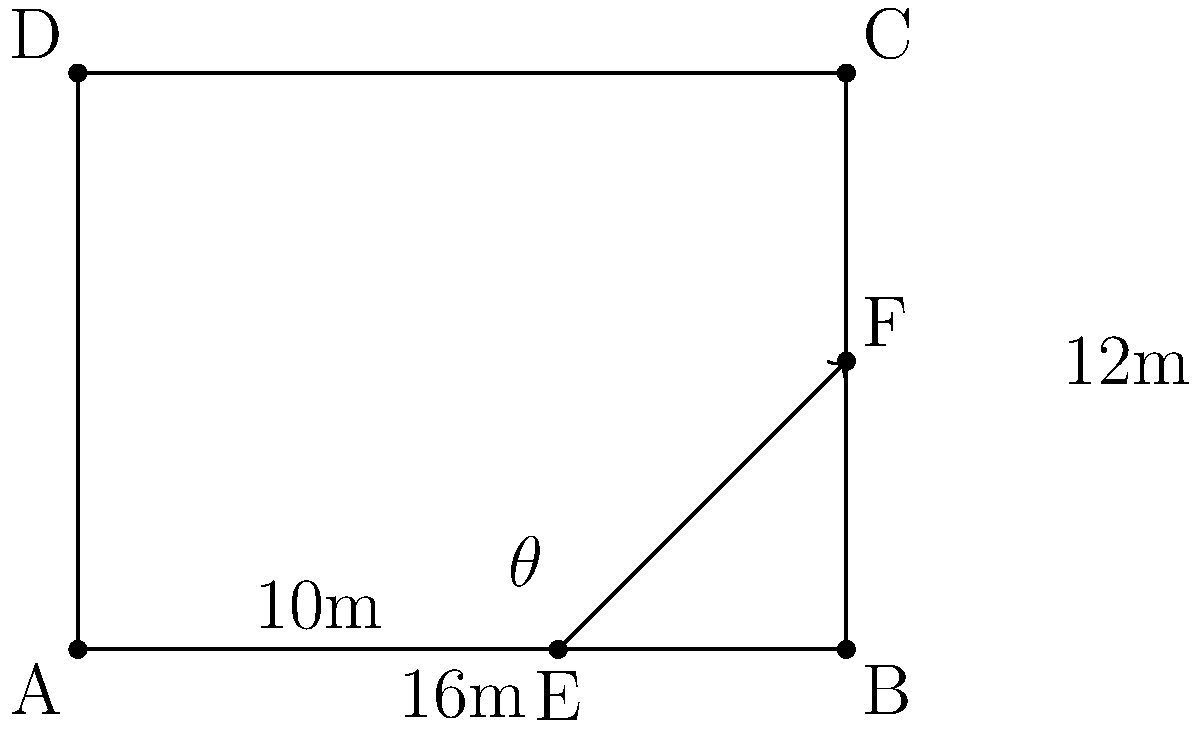During a crucial match in your local soccer league, you're tasked with taking a corner kick. Your Argentine teammate, known for his precise headers, is positioned 10 meters from the corner flag along the goal line. The penalty area extends 16 meters from the goal line and 12 meters from the touch line. To maximize the chances of a successful header, you need to determine the optimal angle $\theta$ for the corner kick. What should be the angle $\theta$ of your kick to reach your teammate at point F? Let's approach this step-by-step:

1) We can treat this as a right-angled triangle problem. The corner flag is at point A, your teammate is at point E, and the target point is F.

2) We know:
   - AE = 10 meters (along the goal line)
   - EF = 12 meters (width of the penalty area)
   - The angle we're looking for is $\theta$ at point E

3) We can use the tangent function to find $\theta$:

   $\tan(\theta) = \frac{\text{opposite}}{\text{adjacent}} = \frac{EF}{AE} = \frac{12}{10}$

4) To find $\theta$, we need to use the inverse tangent (arctangent) function:

   $\theta = \arctan(\frac{12}{10})$

5) Using a calculator or computational tool:

   $\theta = \arctan(1.2) \approx 50.19°$

6) Round to the nearest degree:

   $\theta \approx 50°$

Therefore, you should aim your corner kick at an angle of approximately 50° from the goal line to optimally reach your Argentine teammate.
Answer: $50°$ 